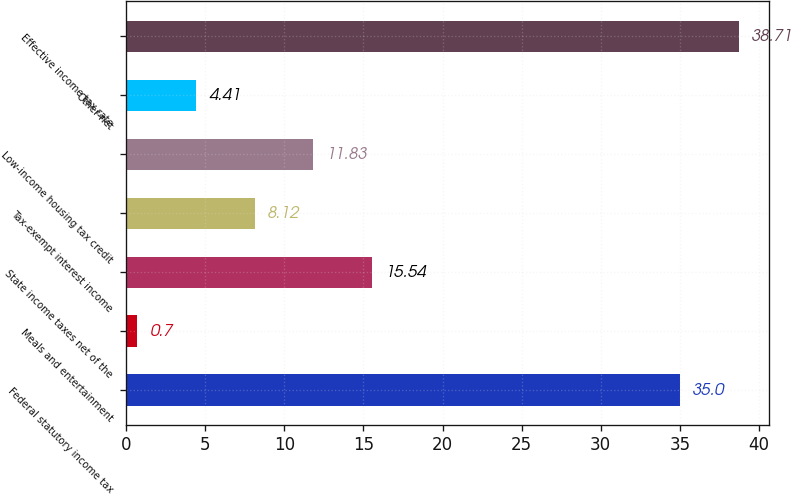<chart> <loc_0><loc_0><loc_500><loc_500><bar_chart><fcel>Federal statutory income tax<fcel>Meals and entertainment<fcel>State income taxes net of the<fcel>Tax-exempt interest income<fcel>Low-income housing tax credit<fcel>Other-net<fcel>Effective income tax rate<nl><fcel>35<fcel>0.7<fcel>15.54<fcel>8.12<fcel>11.83<fcel>4.41<fcel>38.71<nl></chart> 